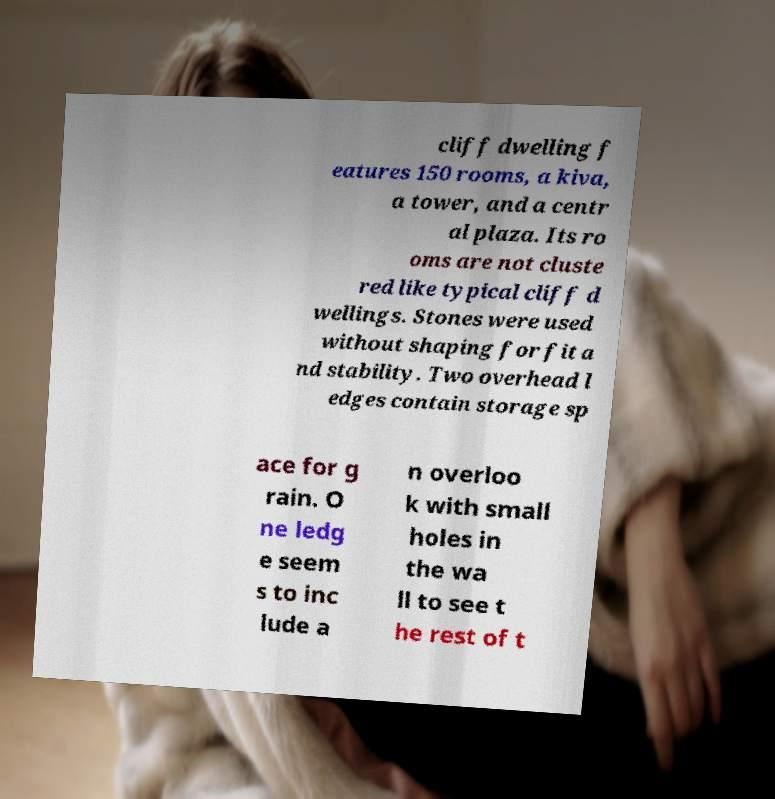I need the written content from this picture converted into text. Can you do that? cliff dwelling f eatures 150 rooms, a kiva, a tower, and a centr al plaza. Its ro oms are not cluste red like typical cliff d wellings. Stones were used without shaping for fit a nd stability. Two overhead l edges contain storage sp ace for g rain. O ne ledg e seem s to inc lude a n overloo k with small holes in the wa ll to see t he rest of t 